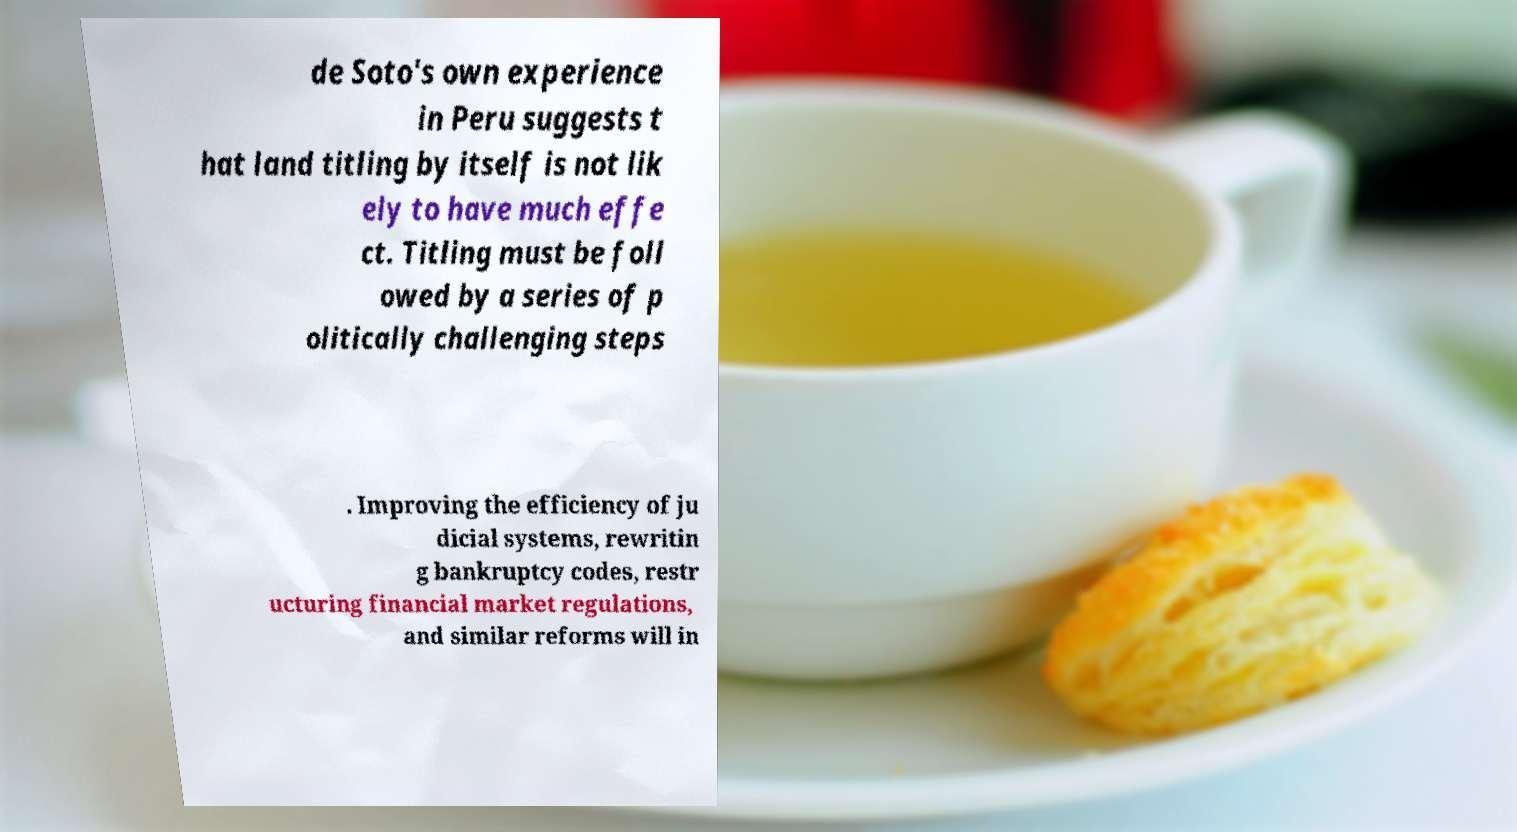I need the written content from this picture converted into text. Can you do that? de Soto's own experience in Peru suggests t hat land titling by itself is not lik ely to have much effe ct. Titling must be foll owed by a series of p olitically challenging steps . Improving the efficiency of ju dicial systems, rewritin g bankruptcy codes, restr ucturing financial market regulations, and similar reforms will in 